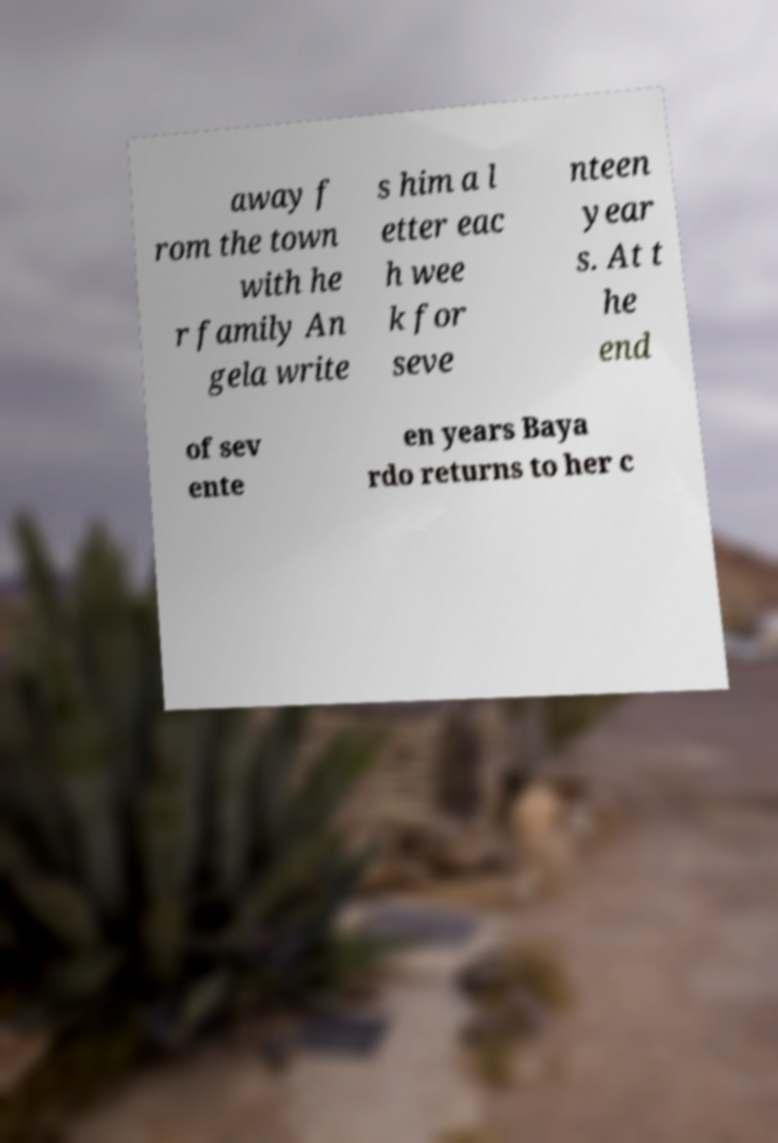Could you assist in decoding the text presented in this image and type it out clearly? away f rom the town with he r family An gela write s him a l etter eac h wee k for seve nteen year s. At t he end of sev ente en years Baya rdo returns to her c 